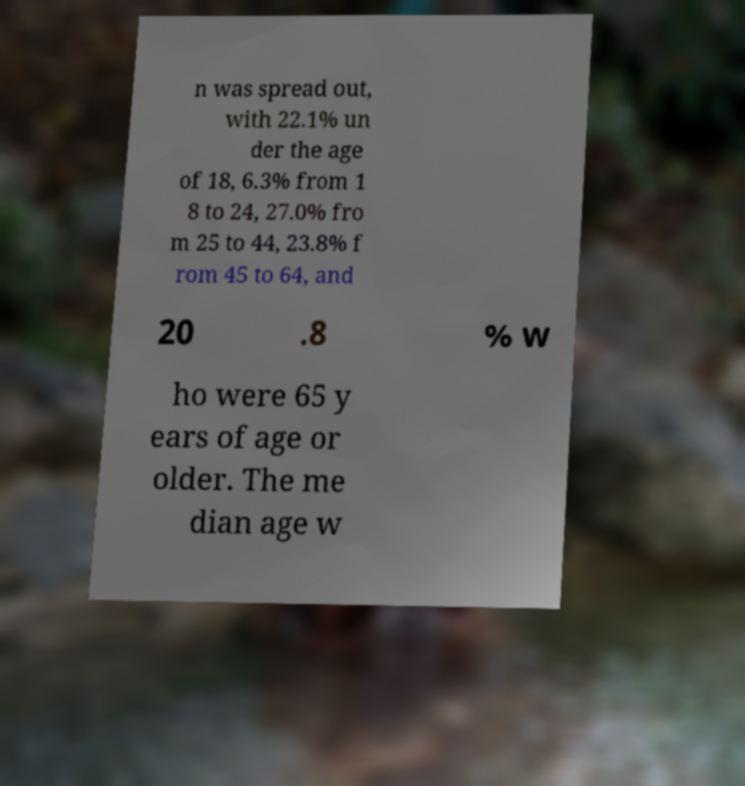Could you extract and type out the text from this image? n was spread out, with 22.1% un der the age of 18, 6.3% from 1 8 to 24, 27.0% fro m 25 to 44, 23.8% f rom 45 to 64, and 20 .8 % w ho were 65 y ears of age or older. The me dian age w 